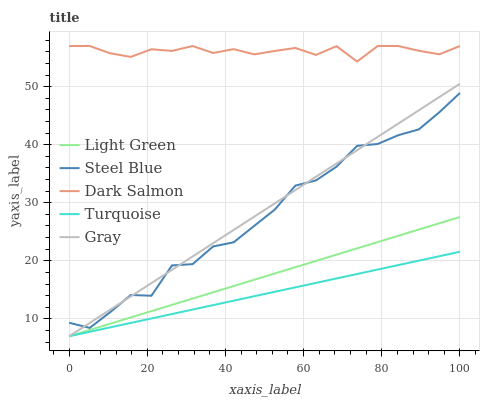Does Turquoise have the minimum area under the curve?
Answer yes or no. Yes. Does Dark Salmon have the maximum area under the curve?
Answer yes or no. Yes. Does Steel Blue have the minimum area under the curve?
Answer yes or no. No. Does Steel Blue have the maximum area under the curve?
Answer yes or no. No. Is Light Green the smoothest?
Answer yes or no. Yes. Is Steel Blue the roughest?
Answer yes or no. Yes. Is Turquoise the smoothest?
Answer yes or no. No. Is Turquoise the roughest?
Answer yes or no. No. Does Gray have the lowest value?
Answer yes or no. Yes. Does Steel Blue have the lowest value?
Answer yes or no. No. Does Dark Salmon have the highest value?
Answer yes or no. Yes. Does Steel Blue have the highest value?
Answer yes or no. No. Is Light Green less than Steel Blue?
Answer yes or no. Yes. Is Dark Salmon greater than Steel Blue?
Answer yes or no. Yes. Does Turquoise intersect Light Green?
Answer yes or no. Yes. Is Turquoise less than Light Green?
Answer yes or no. No. Is Turquoise greater than Light Green?
Answer yes or no. No. Does Light Green intersect Steel Blue?
Answer yes or no. No. 